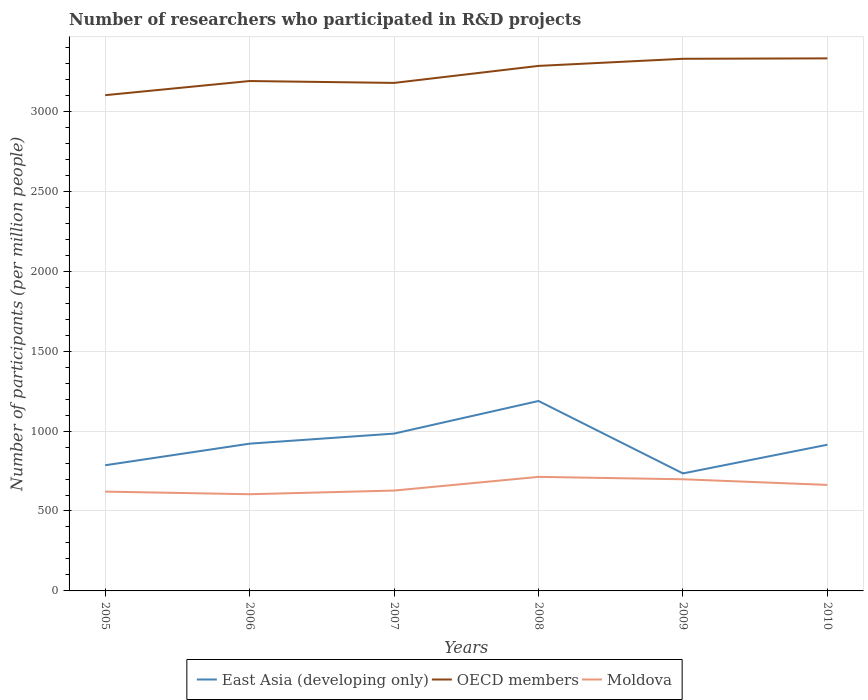How many different coloured lines are there?
Ensure brevity in your answer.  3. Does the line corresponding to OECD members intersect with the line corresponding to Moldova?
Make the answer very short. No. Across all years, what is the maximum number of researchers who participated in R&D projects in OECD members?
Give a very brief answer. 3101.32. In which year was the number of researchers who participated in R&D projects in Moldova maximum?
Make the answer very short. 2006. What is the total number of researchers who participated in R&D projects in East Asia (developing only) in the graph?
Your answer should be compact. 273.66. What is the difference between the highest and the second highest number of researchers who participated in R&D projects in Moldova?
Your answer should be compact. 108.55. What is the difference between the highest and the lowest number of researchers who participated in R&D projects in East Asia (developing only)?
Offer a terse response. 2. How many lines are there?
Make the answer very short. 3. How many years are there in the graph?
Make the answer very short. 6. Are the values on the major ticks of Y-axis written in scientific E-notation?
Keep it short and to the point. No. Does the graph contain any zero values?
Give a very brief answer. No. How are the legend labels stacked?
Your answer should be very brief. Horizontal. What is the title of the graph?
Your response must be concise. Number of researchers who participated in R&D projects. What is the label or title of the X-axis?
Your response must be concise. Years. What is the label or title of the Y-axis?
Provide a succinct answer. Number of participants (per million people). What is the Number of participants (per million people) in East Asia (developing only) in 2005?
Your answer should be compact. 786.17. What is the Number of participants (per million people) in OECD members in 2005?
Offer a terse response. 3101.32. What is the Number of participants (per million people) of Moldova in 2005?
Make the answer very short. 621.26. What is the Number of participants (per million people) in East Asia (developing only) in 2006?
Ensure brevity in your answer.  921.25. What is the Number of participants (per million people) in OECD members in 2006?
Your response must be concise. 3189.88. What is the Number of participants (per million people) in Moldova in 2006?
Your answer should be very brief. 604.88. What is the Number of participants (per million people) in East Asia (developing only) in 2007?
Your response must be concise. 984.15. What is the Number of participants (per million people) in OECD members in 2007?
Offer a very short reply. 3178.1. What is the Number of participants (per million people) in Moldova in 2007?
Make the answer very short. 627.84. What is the Number of participants (per million people) in East Asia (developing only) in 2008?
Your answer should be very brief. 1188.24. What is the Number of participants (per million people) of OECD members in 2008?
Your response must be concise. 3284.49. What is the Number of participants (per million people) of Moldova in 2008?
Offer a terse response. 713.42. What is the Number of participants (per million people) of East Asia (developing only) in 2009?
Your answer should be compact. 735.05. What is the Number of participants (per million people) of OECD members in 2009?
Your response must be concise. 3329.07. What is the Number of participants (per million people) of Moldova in 2009?
Offer a very short reply. 698.52. What is the Number of participants (per million people) of East Asia (developing only) in 2010?
Your response must be concise. 914.57. What is the Number of participants (per million people) in OECD members in 2010?
Give a very brief answer. 3331.63. What is the Number of participants (per million people) of Moldova in 2010?
Ensure brevity in your answer.  663.24. Across all years, what is the maximum Number of participants (per million people) in East Asia (developing only)?
Your answer should be compact. 1188.24. Across all years, what is the maximum Number of participants (per million people) of OECD members?
Offer a very short reply. 3331.63. Across all years, what is the maximum Number of participants (per million people) in Moldova?
Offer a terse response. 713.42. Across all years, what is the minimum Number of participants (per million people) of East Asia (developing only)?
Keep it short and to the point. 735.05. Across all years, what is the minimum Number of participants (per million people) of OECD members?
Provide a short and direct response. 3101.32. Across all years, what is the minimum Number of participants (per million people) of Moldova?
Your answer should be very brief. 604.88. What is the total Number of participants (per million people) of East Asia (developing only) in the graph?
Your response must be concise. 5529.43. What is the total Number of participants (per million people) of OECD members in the graph?
Provide a short and direct response. 1.94e+04. What is the total Number of participants (per million people) of Moldova in the graph?
Ensure brevity in your answer.  3929.15. What is the difference between the Number of participants (per million people) in East Asia (developing only) in 2005 and that in 2006?
Offer a very short reply. -135.08. What is the difference between the Number of participants (per million people) in OECD members in 2005 and that in 2006?
Ensure brevity in your answer.  -88.56. What is the difference between the Number of participants (per million people) of Moldova in 2005 and that in 2006?
Keep it short and to the point. 16.38. What is the difference between the Number of participants (per million people) of East Asia (developing only) in 2005 and that in 2007?
Keep it short and to the point. -197.98. What is the difference between the Number of participants (per million people) in OECD members in 2005 and that in 2007?
Your answer should be compact. -76.77. What is the difference between the Number of participants (per million people) in Moldova in 2005 and that in 2007?
Make the answer very short. -6.58. What is the difference between the Number of participants (per million people) of East Asia (developing only) in 2005 and that in 2008?
Keep it short and to the point. -402.07. What is the difference between the Number of participants (per million people) in OECD members in 2005 and that in 2008?
Keep it short and to the point. -183.16. What is the difference between the Number of participants (per million people) of Moldova in 2005 and that in 2008?
Your response must be concise. -92.17. What is the difference between the Number of participants (per million people) of East Asia (developing only) in 2005 and that in 2009?
Offer a very short reply. 51.12. What is the difference between the Number of participants (per million people) of OECD members in 2005 and that in 2009?
Your answer should be compact. -227.74. What is the difference between the Number of participants (per million people) of Moldova in 2005 and that in 2009?
Your answer should be very brief. -77.26. What is the difference between the Number of participants (per million people) of East Asia (developing only) in 2005 and that in 2010?
Ensure brevity in your answer.  -128.4. What is the difference between the Number of participants (per million people) of OECD members in 2005 and that in 2010?
Your answer should be compact. -230.3. What is the difference between the Number of participants (per million people) of Moldova in 2005 and that in 2010?
Your answer should be compact. -41.99. What is the difference between the Number of participants (per million people) of East Asia (developing only) in 2006 and that in 2007?
Ensure brevity in your answer.  -62.9. What is the difference between the Number of participants (per million people) in OECD members in 2006 and that in 2007?
Your answer should be very brief. 11.78. What is the difference between the Number of participants (per million people) of Moldova in 2006 and that in 2007?
Provide a short and direct response. -22.96. What is the difference between the Number of participants (per million people) in East Asia (developing only) in 2006 and that in 2008?
Your response must be concise. -266.98. What is the difference between the Number of participants (per million people) in OECD members in 2006 and that in 2008?
Provide a short and direct response. -94.6. What is the difference between the Number of participants (per million people) of Moldova in 2006 and that in 2008?
Keep it short and to the point. -108.55. What is the difference between the Number of participants (per million people) in East Asia (developing only) in 2006 and that in 2009?
Offer a very short reply. 186.21. What is the difference between the Number of participants (per million people) in OECD members in 2006 and that in 2009?
Provide a short and direct response. -139.18. What is the difference between the Number of participants (per million people) of Moldova in 2006 and that in 2009?
Ensure brevity in your answer.  -93.64. What is the difference between the Number of participants (per million people) of East Asia (developing only) in 2006 and that in 2010?
Provide a succinct answer. 6.68. What is the difference between the Number of participants (per million people) of OECD members in 2006 and that in 2010?
Your answer should be compact. -141.75. What is the difference between the Number of participants (per million people) in Moldova in 2006 and that in 2010?
Offer a very short reply. -58.37. What is the difference between the Number of participants (per million people) in East Asia (developing only) in 2007 and that in 2008?
Provide a short and direct response. -204.09. What is the difference between the Number of participants (per million people) of OECD members in 2007 and that in 2008?
Keep it short and to the point. -106.39. What is the difference between the Number of participants (per million people) in Moldova in 2007 and that in 2008?
Keep it short and to the point. -85.59. What is the difference between the Number of participants (per million people) of East Asia (developing only) in 2007 and that in 2009?
Give a very brief answer. 249.1. What is the difference between the Number of participants (per million people) of OECD members in 2007 and that in 2009?
Offer a terse response. -150.97. What is the difference between the Number of participants (per million people) in Moldova in 2007 and that in 2009?
Give a very brief answer. -70.68. What is the difference between the Number of participants (per million people) in East Asia (developing only) in 2007 and that in 2010?
Your answer should be compact. 69.58. What is the difference between the Number of participants (per million people) in OECD members in 2007 and that in 2010?
Your response must be concise. -153.53. What is the difference between the Number of participants (per million people) in Moldova in 2007 and that in 2010?
Your answer should be very brief. -35.4. What is the difference between the Number of participants (per million people) of East Asia (developing only) in 2008 and that in 2009?
Offer a very short reply. 453.19. What is the difference between the Number of participants (per million people) of OECD members in 2008 and that in 2009?
Your answer should be compact. -44.58. What is the difference between the Number of participants (per million people) in Moldova in 2008 and that in 2009?
Provide a succinct answer. 14.9. What is the difference between the Number of participants (per million people) in East Asia (developing only) in 2008 and that in 2010?
Your response must be concise. 273.66. What is the difference between the Number of participants (per million people) in OECD members in 2008 and that in 2010?
Your response must be concise. -47.14. What is the difference between the Number of participants (per million people) in Moldova in 2008 and that in 2010?
Provide a succinct answer. 50.18. What is the difference between the Number of participants (per million people) of East Asia (developing only) in 2009 and that in 2010?
Give a very brief answer. -179.53. What is the difference between the Number of participants (per million people) of OECD members in 2009 and that in 2010?
Make the answer very short. -2.56. What is the difference between the Number of participants (per million people) of Moldova in 2009 and that in 2010?
Provide a short and direct response. 35.28. What is the difference between the Number of participants (per million people) in East Asia (developing only) in 2005 and the Number of participants (per million people) in OECD members in 2006?
Make the answer very short. -2403.71. What is the difference between the Number of participants (per million people) in East Asia (developing only) in 2005 and the Number of participants (per million people) in Moldova in 2006?
Provide a succinct answer. 181.29. What is the difference between the Number of participants (per million people) of OECD members in 2005 and the Number of participants (per million people) of Moldova in 2006?
Make the answer very short. 2496.45. What is the difference between the Number of participants (per million people) of East Asia (developing only) in 2005 and the Number of participants (per million people) of OECD members in 2007?
Your response must be concise. -2391.93. What is the difference between the Number of participants (per million people) in East Asia (developing only) in 2005 and the Number of participants (per million people) in Moldova in 2007?
Offer a very short reply. 158.33. What is the difference between the Number of participants (per million people) in OECD members in 2005 and the Number of participants (per million people) in Moldova in 2007?
Ensure brevity in your answer.  2473.49. What is the difference between the Number of participants (per million people) of East Asia (developing only) in 2005 and the Number of participants (per million people) of OECD members in 2008?
Your response must be concise. -2498.32. What is the difference between the Number of participants (per million people) in East Asia (developing only) in 2005 and the Number of participants (per million people) in Moldova in 2008?
Offer a terse response. 72.75. What is the difference between the Number of participants (per million people) in OECD members in 2005 and the Number of participants (per million people) in Moldova in 2008?
Offer a very short reply. 2387.9. What is the difference between the Number of participants (per million people) of East Asia (developing only) in 2005 and the Number of participants (per million people) of OECD members in 2009?
Give a very brief answer. -2542.89. What is the difference between the Number of participants (per million people) of East Asia (developing only) in 2005 and the Number of participants (per million people) of Moldova in 2009?
Offer a very short reply. 87.65. What is the difference between the Number of participants (per million people) of OECD members in 2005 and the Number of participants (per million people) of Moldova in 2009?
Provide a succinct answer. 2402.81. What is the difference between the Number of participants (per million people) of East Asia (developing only) in 2005 and the Number of participants (per million people) of OECD members in 2010?
Give a very brief answer. -2545.46. What is the difference between the Number of participants (per million people) of East Asia (developing only) in 2005 and the Number of participants (per million people) of Moldova in 2010?
Your answer should be very brief. 122.93. What is the difference between the Number of participants (per million people) of OECD members in 2005 and the Number of participants (per million people) of Moldova in 2010?
Your answer should be very brief. 2438.08. What is the difference between the Number of participants (per million people) in East Asia (developing only) in 2006 and the Number of participants (per million people) in OECD members in 2007?
Give a very brief answer. -2256.84. What is the difference between the Number of participants (per million people) in East Asia (developing only) in 2006 and the Number of participants (per million people) in Moldova in 2007?
Make the answer very short. 293.42. What is the difference between the Number of participants (per million people) in OECD members in 2006 and the Number of participants (per million people) in Moldova in 2007?
Your answer should be very brief. 2562.05. What is the difference between the Number of participants (per million people) in East Asia (developing only) in 2006 and the Number of participants (per million people) in OECD members in 2008?
Provide a short and direct response. -2363.23. What is the difference between the Number of participants (per million people) in East Asia (developing only) in 2006 and the Number of participants (per million people) in Moldova in 2008?
Offer a very short reply. 207.83. What is the difference between the Number of participants (per million people) in OECD members in 2006 and the Number of participants (per million people) in Moldova in 2008?
Your answer should be compact. 2476.46. What is the difference between the Number of participants (per million people) of East Asia (developing only) in 2006 and the Number of participants (per million people) of OECD members in 2009?
Your answer should be compact. -2407.81. What is the difference between the Number of participants (per million people) of East Asia (developing only) in 2006 and the Number of participants (per million people) of Moldova in 2009?
Your response must be concise. 222.74. What is the difference between the Number of participants (per million people) in OECD members in 2006 and the Number of participants (per million people) in Moldova in 2009?
Give a very brief answer. 2491.36. What is the difference between the Number of participants (per million people) of East Asia (developing only) in 2006 and the Number of participants (per million people) of OECD members in 2010?
Make the answer very short. -2410.38. What is the difference between the Number of participants (per million people) in East Asia (developing only) in 2006 and the Number of participants (per million people) in Moldova in 2010?
Keep it short and to the point. 258.01. What is the difference between the Number of participants (per million people) in OECD members in 2006 and the Number of participants (per million people) in Moldova in 2010?
Provide a succinct answer. 2526.64. What is the difference between the Number of participants (per million people) in East Asia (developing only) in 2007 and the Number of participants (per million people) in OECD members in 2008?
Provide a succinct answer. -2300.34. What is the difference between the Number of participants (per million people) in East Asia (developing only) in 2007 and the Number of participants (per million people) in Moldova in 2008?
Your response must be concise. 270.73. What is the difference between the Number of participants (per million people) of OECD members in 2007 and the Number of participants (per million people) of Moldova in 2008?
Provide a short and direct response. 2464.68. What is the difference between the Number of participants (per million people) in East Asia (developing only) in 2007 and the Number of participants (per million people) in OECD members in 2009?
Offer a terse response. -2344.92. What is the difference between the Number of participants (per million people) of East Asia (developing only) in 2007 and the Number of participants (per million people) of Moldova in 2009?
Provide a succinct answer. 285.63. What is the difference between the Number of participants (per million people) in OECD members in 2007 and the Number of participants (per million people) in Moldova in 2009?
Give a very brief answer. 2479.58. What is the difference between the Number of participants (per million people) in East Asia (developing only) in 2007 and the Number of participants (per million people) in OECD members in 2010?
Your answer should be compact. -2347.48. What is the difference between the Number of participants (per million people) in East Asia (developing only) in 2007 and the Number of participants (per million people) in Moldova in 2010?
Ensure brevity in your answer.  320.91. What is the difference between the Number of participants (per million people) in OECD members in 2007 and the Number of participants (per million people) in Moldova in 2010?
Provide a short and direct response. 2514.86. What is the difference between the Number of participants (per million people) of East Asia (developing only) in 2008 and the Number of participants (per million people) of OECD members in 2009?
Make the answer very short. -2140.83. What is the difference between the Number of participants (per million people) in East Asia (developing only) in 2008 and the Number of participants (per million people) in Moldova in 2009?
Ensure brevity in your answer.  489.72. What is the difference between the Number of participants (per million people) in OECD members in 2008 and the Number of participants (per million people) in Moldova in 2009?
Keep it short and to the point. 2585.97. What is the difference between the Number of participants (per million people) of East Asia (developing only) in 2008 and the Number of participants (per million people) of OECD members in 2010?
Offer a very short reply. -2143.39. What is the difference between the Number of participants (per million people) of East Asia (developing only) in 2008 and the Number of participants (per million people) of Moldova in 2010?
Provide a succinct answer. 525. What is the difference between the Number of participants (per million people) of OECD members in 2008 and the Number of participants (per million people) of Moldova in 2010?
Give a very brief answer. 2621.25. What is the difference between the Number of participants (per million people) of East Asia (developing only) in 2009 and the Number of participants (per million people) of OECD members in 2010?
Offer a very short reply. -2596.58. What is the difference between the Number of participants (per million people) in East Asia (developing only) in 2009 and the Number of participants (per million people) in Moldova in 2010?
Your answer should be compact. 71.8. What is the difference between the Number of participants (per million people) of OECD members in 2009 and the Number of participants (per million people) of Moldova in 2010?
Your answer should be compact. 2665.82. What is the average Number of participants (per million people) of East Asia (developing only) per year?
Make the answer very short. 921.57. What is the average Number of participants (per million people) in OECD members per year?
Make the answer very short. 3235.75. What is the average Number of participants (per million people) of Moldova per year?
Your answer should be very brief. 654.86. In the year 2005, what is the difference between the Number of participants (per million people) of East Asia (developing only) and Number of participants (per million people) of OECD members?
Your answer should be very brief. -2315.15. In the year 2005, what is the difference between the Number of participants (per million people) in East Asia (developing only) and Number of participants (per million people) in Moldova?
Your response must be concise. 164.91. In the year 2005, what is the difference between the Number of participants (per million people) in OECD members and Number of participants (per million people) in Moldova?
Keep it short and to the point. 2480.07. In the year 2006, what is the difference between the Number of participants (per million people) in East Asia (developing only) and Number of participants (per million people) in OECD members?
Give a very brief answer. -2268.63. In the year 2006, what is the difference between the Number of participants (per million people) of East Asia (developing only) and Number of participants (per million people) of Moldova?
Make the answer very short. 316.38. In the year 2006, what is the difference between the Number of participants (per million people) in OECD members and Number of participants (per million people) in Moldova?
Ensure brevity in your answer.  2585.01. In the year 2007, what is the difference between the Number of participants (per million people) in East Asia (developing only) and Number of participants (per million people) in OECD members?
Give a very brief answer. -2193.95. In the year 2007, what is the difference between the Number of participants (per million people) in East Asia (developing only) and Number of participants (per million people) in Moldova?
Your answer should be very brief. 356.31. In the year 2007, what is the difference between the Number of participants (per million people) of OECD members and Number of participants (per million people) of Moldova?
Keep it short and to the point. 2550.26. In the year 2008, what is the difference between the Number of participants (per million people) of East Asia (developing only) and Number of participants (per million people) of OECD members?
Ensure brevity in your answer.  -2096.25. In the year 2008, what is the difference between the Number of participants (per million people) of East Asia (developing only) and Number of participants (per million people) of Moldova?
Make the answer very short. 474.81. In the year 2008, what is the difference between the Number of participants (per million people) of OECD members and Number of participants (per million people) of Moldova?
Ensure brevity in your answer.  2571.06. In the year 2009, what is the difference between the Number of participants (per million people) in East Asia (developing only) and Number of participants (per million people) in OECD members?
Give a very brief answer. -2594.02. In the year 2009, what is the difference between the Number of participants (per million people) of East Asia (developing only) and Number of participants (per million people) of Moldova?
Make the answer very short. 36.53. In the year 2009, what is the difference between the Number of participants (per million people) in OECD members and Number of participants (per million people) in Moldova?
Ensure brevity in your answer.  2630.55. In the year 2010, what is the difference between the Number of participants (per million people) in East Asia (developing only) and Number of participants (per million people) in OECD members?
Keep it short and to the point. -2417.05. In the year 2010, what is the difference between the Number of participants (per million people) of East Asia (developing only) and Number of participants (per million people) of Moldova?
Provide a succinct answer. 251.33. In the year 2010, what is the difference between the Number of participants (per million people) in OECD members and Number of participants (per million people) in Moldova?
Provide a short and direct response. 2668.39. What is the ratio of the Number of participants (per million people) of East Asia (developing only) in 2005 to that in 2006?
Offer a terse response. 0.85. What is the ratio of the Number of participants (per million people) of OECD members in 2005 to that in 2006?
Ensure brevity in your answer.  0.97. What is the ratio of the Number of participants (per million people) of Moldova in 2005 to that in 2006?
Give a very brief answer. 1.03. What is the ratio of the Number of participants (per million people) in East Asia (developing only) in 2005 to that in 2007?
Provide a short and direct response. 0.8. What is the ratio of the Number of participants (per million people) in OECD members in 2005 to that in 2007?
Keep it short and to the point. 0.98. What is the ratio of the Number of participants (per million people) of East Asia (developing only) in 2005 to that in 2008?
Offer a terse response. 0.66. What is the ratio of the Number of participants (per million people) in OECD members in 2005 to that in 2008?
Keep it short and to the point. 0.94. What is the ratio of the Number of participants (per million people) of Moldova in 2005 to that in 2008?
Your answer should be compact. 0.87. What is the ratio of the Number of participants (per million people) of East Asia (developing only) in 2005 to that in 2009?
Provide a succinct answer. 1.07. What is the ratio of the Number of participants (per million people) in OECD members in 2005 to that in 2009?
Provide a short and direct response. 0.93. What is the ratio of the Number of participants (per million people) of Moldova in 2005 to that in 2009?
Your answer should be compact. 0.89. What is the ratio of the Number of participants (per million people) of East Asia (developing only) in 2005 to that in 2010?
Your answer should be very brief. 0.86. What is the ratio of the Number of participants (per million people) in OECD members in 2005 to that in 2010?
Give a very brief answer. 0.93. What is the ratio of the Number of participants (per million people) in Moldova in 2005 to that in 2010?
Your answer should be very brief. 0.94. What is the ratio of the Number of participants (per million people) in East Asia (developing only) in 2006 to that in 2007?
Your response must be concise. 0.94. What is the ratio of the Number of participants (per million people) of OECD members in 2006 to that in 2007?
Provide a succinct answer. 1. What is the ratio of the Number of participants (per million people) of Moldova in 2006 to that in 2007?
Your response must be concise. 0.96. What is the ratio of the Number of participants (per million people) in East Asia (developing only) in 2006 to that in 2008?
Your answer should be compact. 0.78. What is the ratio of the Number of participants (per million people) in OECD members in 2006 to that in 2008?
Offer a terse response. 0.97. What is the ratio of the Number of participants (per million people) of Moldova in 2006 to that in 2008?
Offer a very short reply. 0.85. What is the ratio of the Number of participants (per million people) of East Asia (developing only) in 2006 to that in 2009?
Provide a short and direct response. 1.25. What is the ratio of the Number of participants (per million people) in OECD members in 2006 to that in 2009?
Ensure brevity in your answer.  0.96. What is the ratio of the Number of participants (per million people) in Moldova in 2006 to that in 2009?
Give a very brief answer. 0.87. What is the ratio of the Number of participants (per million people) of East Asia (developing only) in 2006 to that in 2010?
Provide a succinct answer. 1.01. What is the ratio of the Number of participants (per million people) of OECD members in 2006 to that in 2010?
Offer a terse response. 0.96. What is the ratio of the Number of participants (per million people) of Moldova in 2006 to that in 2010?
Your response must be concise. 0.91. What is the ratio of the Number of participants (per million people) of East Asia (developing only) in 2007 to that in 2008?
Offer a terse response. 0.83. What is the ratio of the Number of participants (per million people) of OECD members in 2007 to that in 2008?
Provide a short and direct response. 0.97. What is the ratio of the Number of participants (per million people) in East Asia (developing only) in 2007 to that in 2009?
Offer a terse response. 1.34. What is the ratio of the Number of participants (per million people) of OECD members in 2007 to that in 2009?
Your answer should be very brief. 0.95. What is the ratio of the Number of participants (per million people) of Moldova in 2007 to that in 2009?
Ensure brevity in your answer.  0.9. What is the ratio of the Number of participants (per million people) of East Asia (developing only) in 2007 to that in 2010?
Offer a very short reply. 1.08. What is the ratio of the Number of participants (per million people) of OECD members in 2007 to that in 2010?
Give a very brief answer. 0.95. What is the ratio of the Number of participants (per million people) in Moldova in 2007 to that in 2010?
Your response must be concise. 0.95. What is the ratio of the Number of participants (per million people) in East Asia (developing only) in 2008 to that in 2009?
Make the answer very short. 1.62. What is the ratio of the Number of participants (per million people) of OECD members in 2008 to that in 2009?
Ensure brevity in your answer.  0.99. What is the ratio of the Number of participants (per million people) of Moldova in 2008 to that in 2009?
Offer a terse response. 1.02. What is the ratio of the Number of participants (per million people) of East Asia (developing only) in 2008 to that in 2010?
Your response must be concise. 1.3. What is the ratio of the Number of participants (per million people) of OECD members in 2008 to that in 2010?
Keep it short and to the point. 0.99. What is the ratio of the Number of participants (per million people) of Moldova in 2008 to that in 2010?
Your response must be concise. 1.08. What is the ratio of the Number of participants (per million people) of East Asia (developing only) in 2009 to that in 2010?
Your answer should be compact. 0.8. What is the ratio of the Number of participants (per million people) in OECD members in 2009 to that in 2010?
Give a very brief answer. 1. What is the ratio of the Number of participants (per million people) in Moldova in 2009 to that in 2010?
Ensure brevity in your answer.  1.05. What is the difference between the highest and the second highest Number of participants (per million people) of East Asia (developing only)?
Your answer should be compact. 204.09. What is the difference between the highest and the second highest Number of participants (per million people) in OECD members?
Give a very brief answer. 2.56. What is the difference between the highest and the second highest Number of participants (per million people) of Moldova?
Your answer should be very brief. 14.9. What is the difference between the highest and the lowest Number of participants (per million people) in East Asia (developing only)?
Your answer should be compact. 453.19. What is the difference between the highest and the lowest Number of participants (per million people) in OECD members?
Your answer should be very brief. 230.3. What is the difference between the highest and the lowest Number of participants (per million people) in Moldova?
Provide a succinct answer. 108.55. 